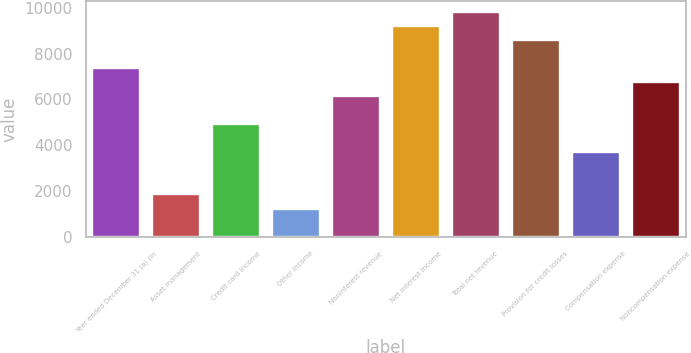<chart> <loc_0><loc_0><loc_500><loc_500><bar_chart><fcel>Year ended December 31 (a) (in<fcel>Asset management<fcel>Credit card income<fcel>Other income<fcel>Noninterest revenue<fcel>Net interest income<fcel>Total net revenue<fcel>Provision for credit losses<fcel>Compensation expense<fcel>Noncompensation expense<nl><fcel>7368.8<fcel>1857.2<fcel>4919.2<fcel>1244.8<fcel>6144<fcel>9206<fcel>9818.4<fcel>8593.6<fcel>3694.4<fcel>6756.4<nl></chart> 